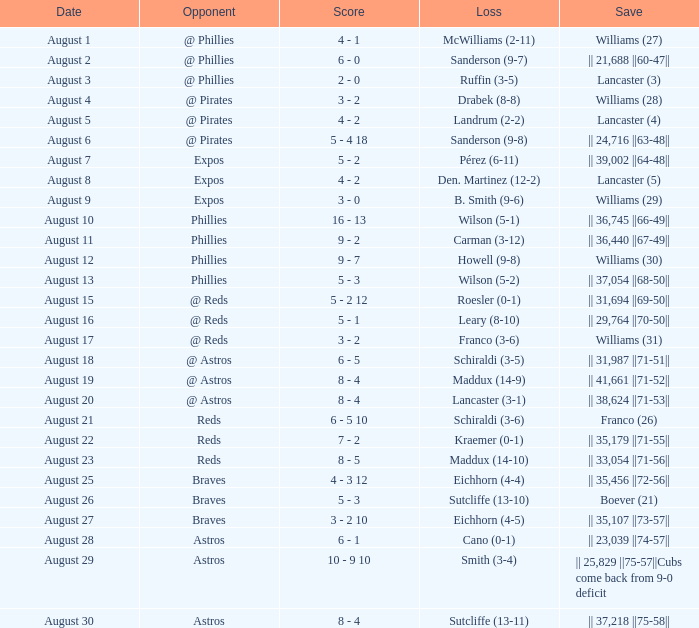Name the opponent with loss of sanderson (9-8) @ Pirates. 